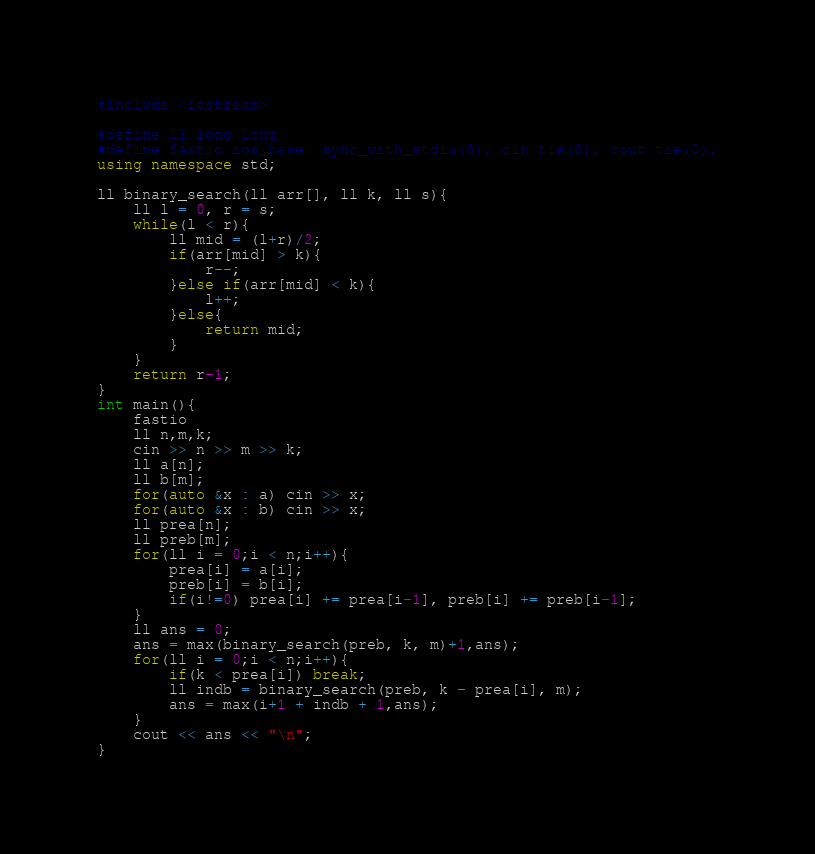<code> <loc_0><loc_0><loc_500><loc_500><_C++_>#include <iostream>

#define ll long long
#define fastio ios_base::sync_with_stdio(0); cin.tie(0); cout.tie(0);
using namespace std;

ll binary_search(ll arr[], ll k, ll s){
	ll l = 0, r = s;
	while(l < r){
		ll mid = (l+r)/2;
		if(arr[mid] > k){
			r--;
		}else if(arr[mid] < k){
			l++;
		}else{
			return mid;
		}
	}
	return r-1;
}
int main(){
	fastio
	ll n,m,k;
	cin >> n >> m >> k;
	ll a[n];
	ll b[m];
	for(auto &x : a) cin >> x;
	for(auto &x : b) cin >> x;
	ll prea[n];
	ll preb[m];
	for(ll i = 0;i < n;i++){
		prea[i] = a[i];
		preb[i] = b[i];
		if(i!=0) prea[i] += prea[i-1], preb[i] += preb[i-1];
	}
	ll ans = 0;
	ans = max(binary_search(preb, k, m)+1,ans);
	for(ll i = 0;i < n;i++){
		if(k < prea[i]) break;
		ll indb = binary_search(preb, k - prea[i], m);
		ans = max(i+1 + indb + 1,ans);
	}
	cout << ans << "\n";
}	</code> 